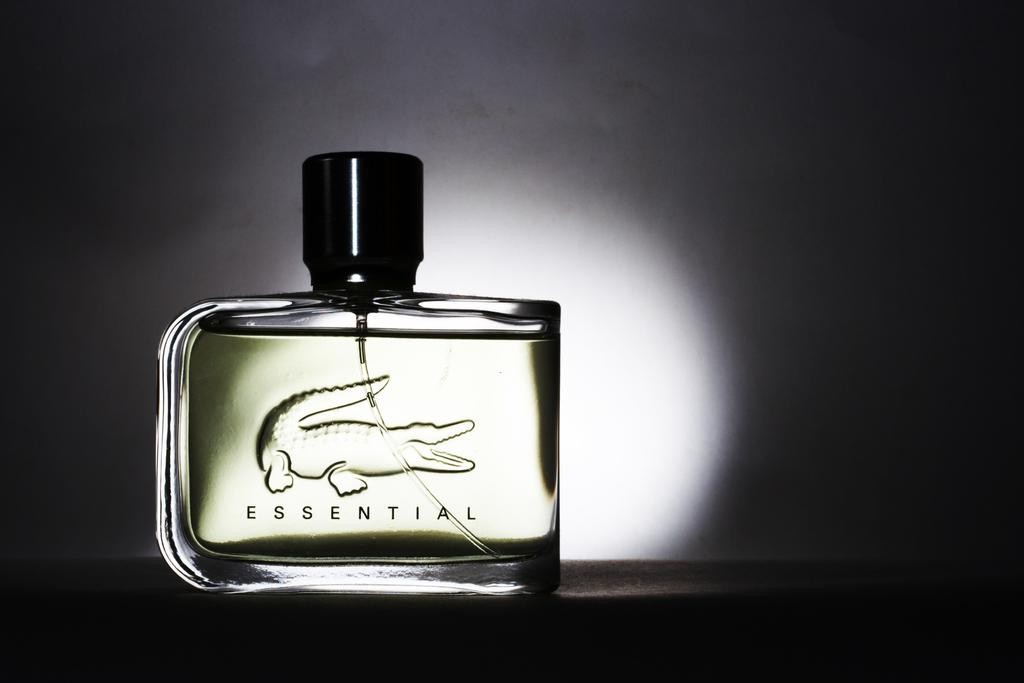<image>
Relay a brief, clear account of the picture shown. a small chologne bottle with the word 'essential' on it 